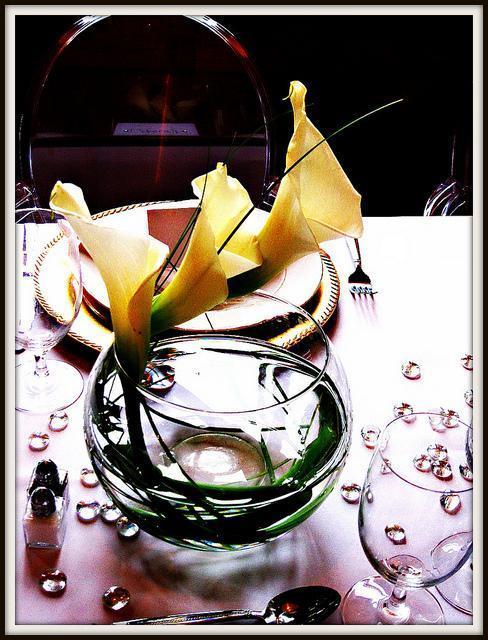How many wine glasses are there?
Give a very brief answer. 2. How many chairs are in the picture?
Give a very brief answer. 1. How many people are holding umbrellas?
Give a very brief answer. 0. 